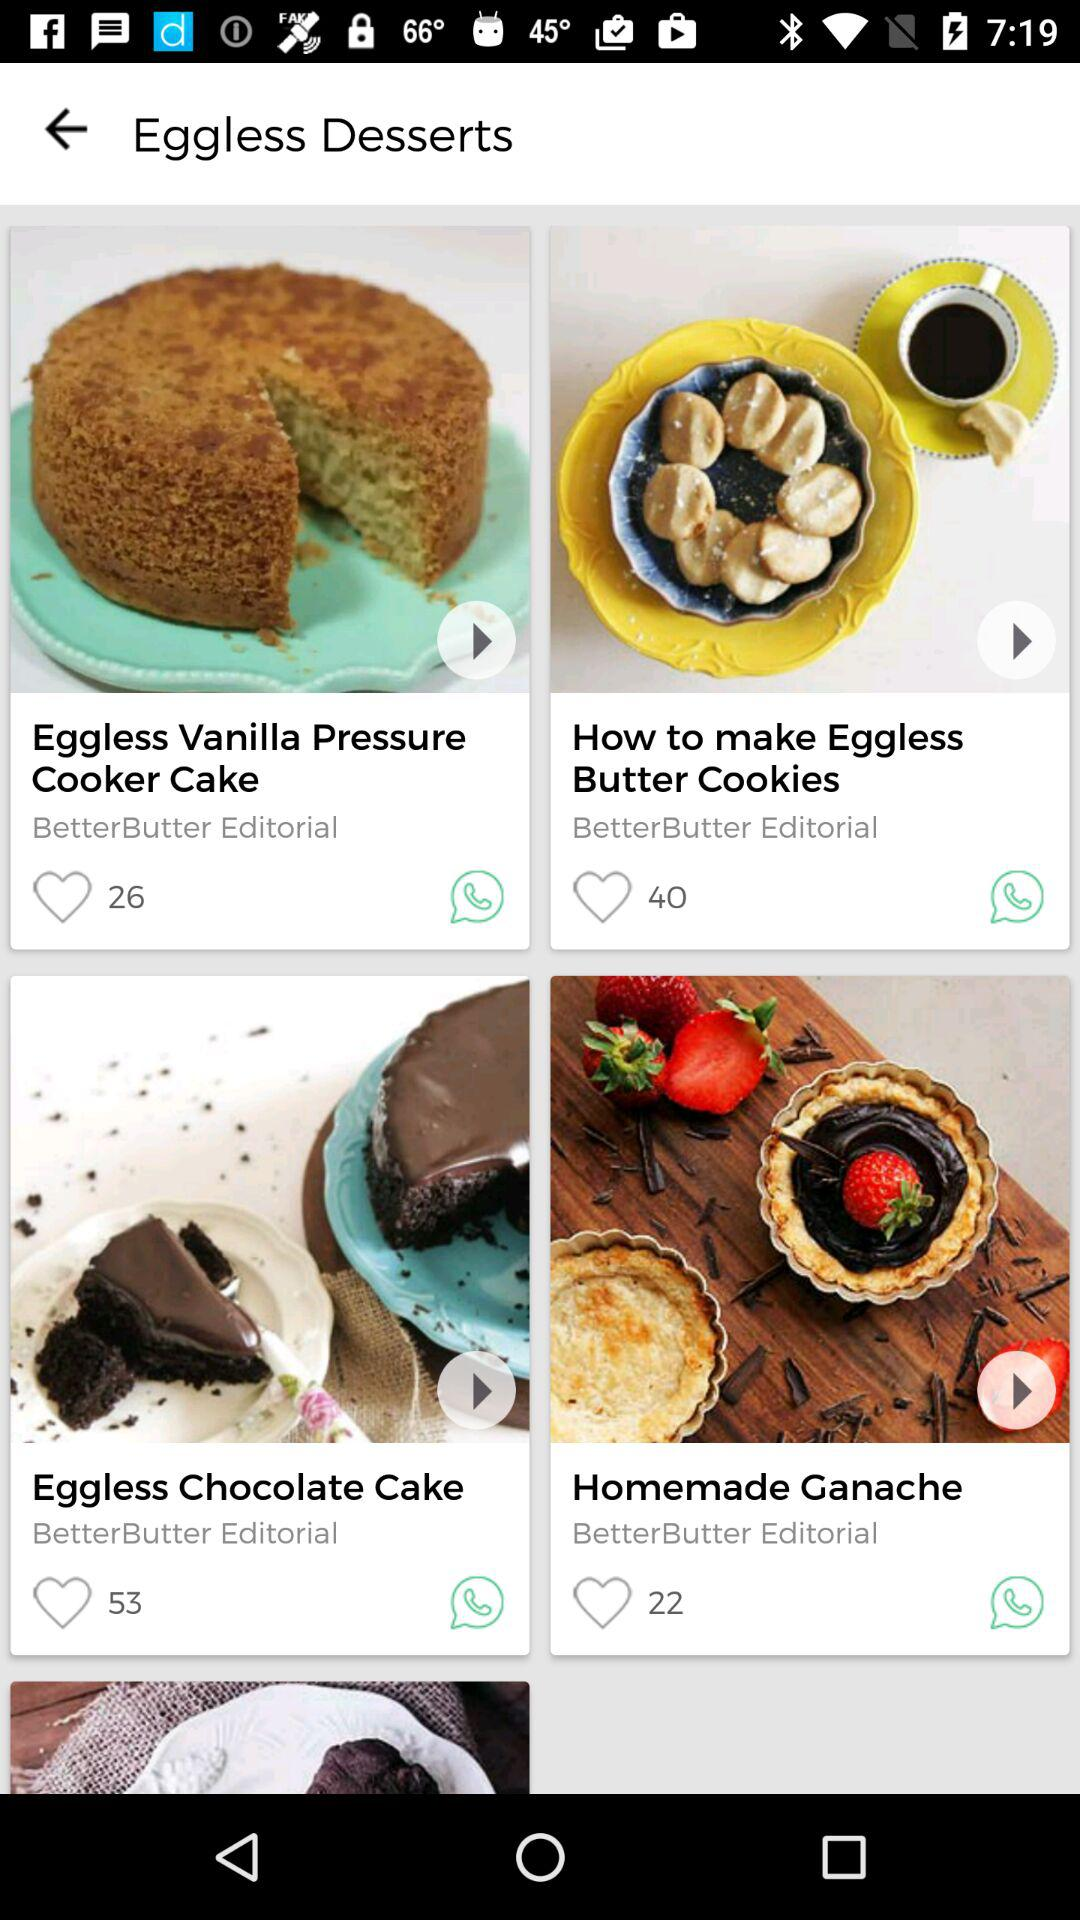How many likes did Homemade Ganache get? Homemade Ganache got 22 likes. 